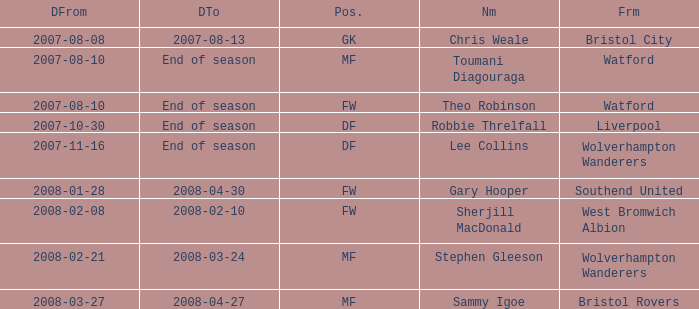Where was the player from who had the position of DF, who started 2007-10-30? Liverpool. 